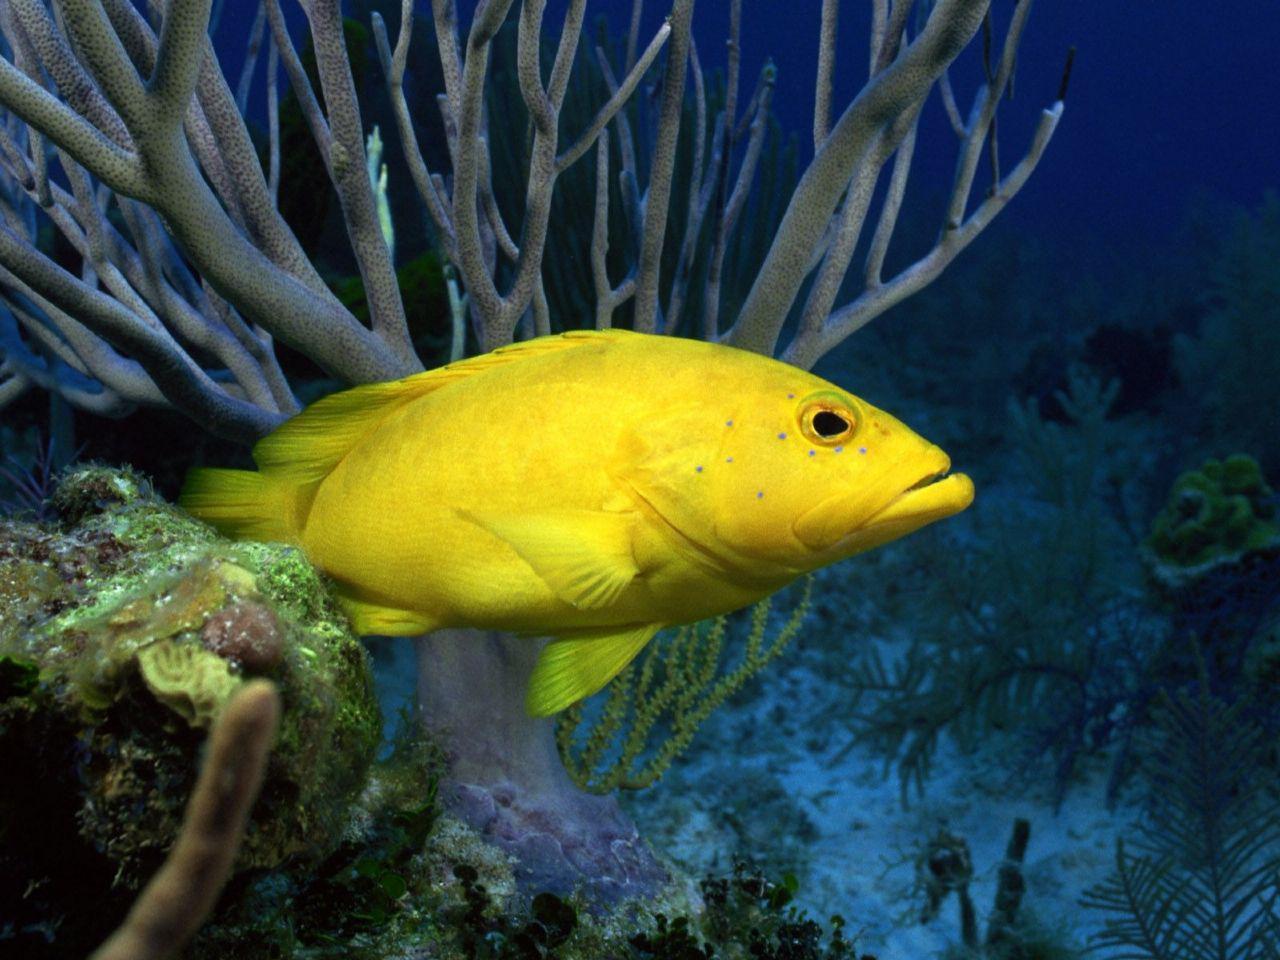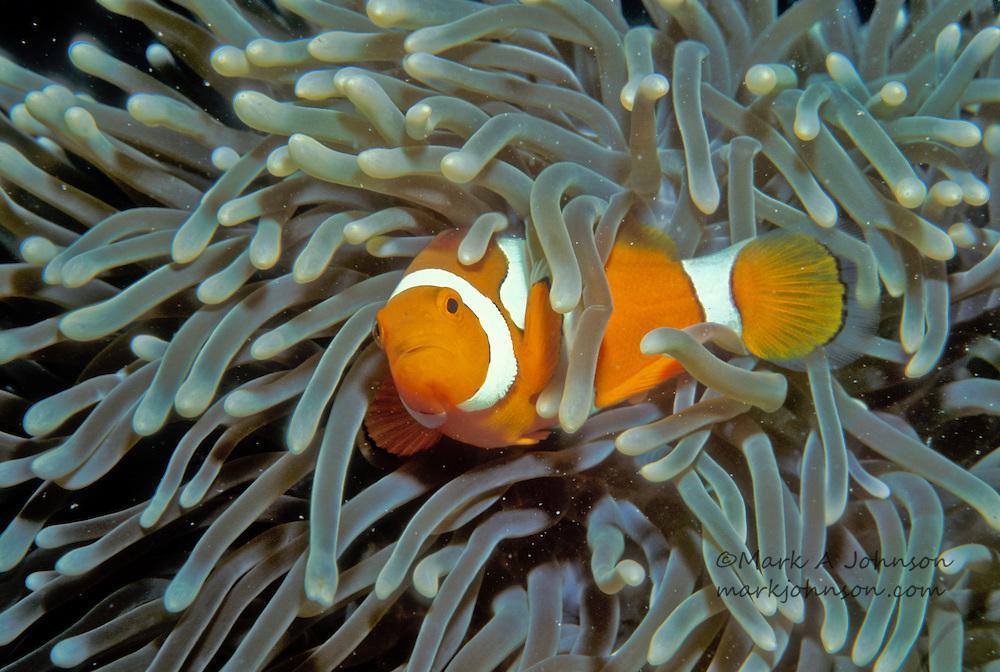The first image is the image on the left, the second image is the image on the right. Given the left and right images, does the statement "there is only clownfish on the right image" hold true? Answer yes or no. Yes. 